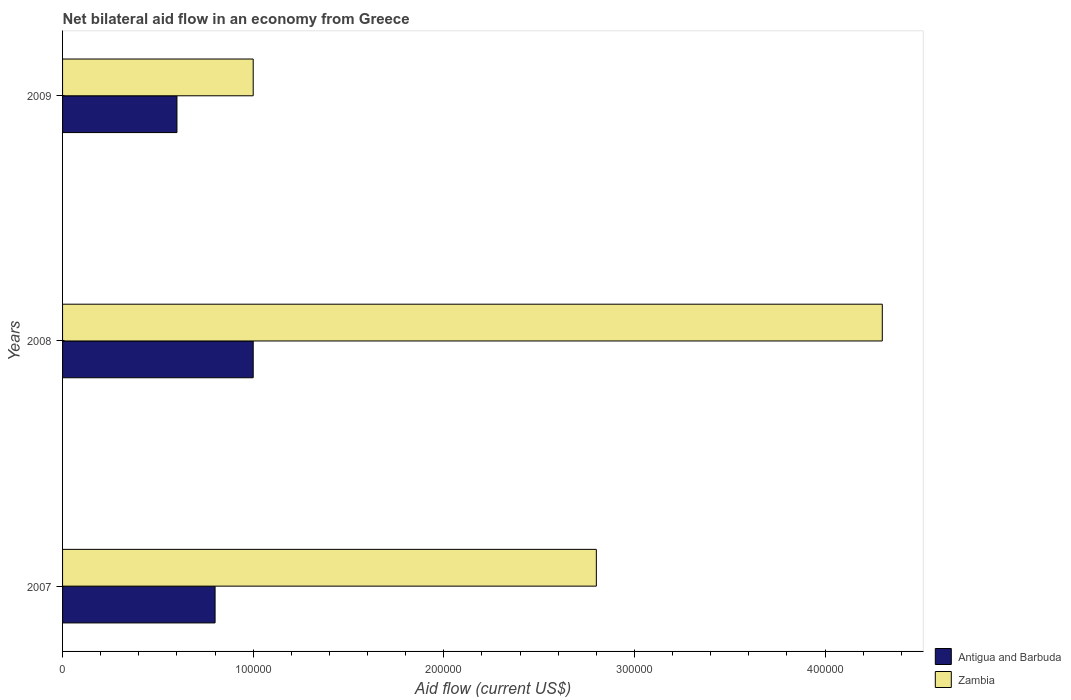How many groups of bars are there?
Your answer should be compact. 3. How many bars are there on the 3rd tick from the top?
Your response must be concise. 2. In how many cases, is the number of bars for a given year not equal to the number of legend labels?
Provide a short and direct response. 0. What is the net bilateral aid flow in Zambia in 2007?
Make the answer very short. 2.80e+05. Across all years, what is the minimum net bilateral aid flow in Antigua and Barbuda?
Keep it short and to the point. 6.00e+04. In which year was the net bilateral aid flow in Zambia maximum?
Ensure brevity in your answer.  2008. In which year was the net bilateral aid flow in Zambia minimum?
Offer a terse response. 2009. What is the total net bilateral aid flow in Zambia in the graph?
Provide a short and direct response. 8.10e+05. What is the difference between the net bilateral aid flow in Zambia in 2007 and that in 2008?
Provide a succinct answer. -1.50e+05. What is the difference between the net bilateral aid flow in Antigua and Barbuda in 2009 and the net bilateral aid flow in Zambia in 2008?
Provide a succinct answer. -3.70e+05. What is the average net bilateral aid flow in Antigua and Barbuda per year?
Your answer should be compact. 8.00e+04. In the year 2009, what is the difference between the net bilateral aid flow in Antigua and Barbuda and net bilateral aid flow in Zambia?
Provide a succinct answer. -4.00e+04. In how many years, is the net bilateral aid flow in Zambia greater than 100000 US$?
Your response must be concise. 2. What is the ratio of the net bilateral aid flow in Antigua and Barbuda in 2007 to that in 2008?
Make the answer very short. 0.8. Is the net bilateral aid flow in Zambia in 2008 less than that in 2009?
Give a very brief answer. No. Is the difference between the net bilateral aid flow in Antigua and Barbuda in 2008 and 2009 greater than the difference between the net bilateral aid flow in Zambia in 2008 and 2009?
Your answer should be very brief. No. What is the difference between the highest and the second highest net bilateral aid flow in Antigua and Barbuda?
Provide a succinct answer. 2.00e+04. In how many years, is the net bilateral aid flow in Zambia greater than the average net bilateral aid flow in Zambia taken over all years?
Give a very brief answer. 2. What does the 1st bar from the top in 2007 represents?
Make the answer very short. Zambia. What does the 2nd bar from the bottom in 2007 represents?
Your response must be concise. Zambia. How many bars are there?
Ensure brevity in your answer.  6. Are all the bars in the graph horizontal?
Keep it short and to the point. Yes. How many years are there in the graph?
Keep it short and to the point. 3. What is the difference between two consecutive major ticks on the X-axis?
Provide a short and direct response. 1.00e+05. Does the graph contain any zero values?
Give a very brief answer. No. How are the legend labels stacked?
Offer a very short reply. Vertical. What is the title of the graph?
Give a very brief answer. Net bilateral aid flow in an economy from Greece. What is the label or title of the Y-axis?
Offer a terse response. Years. What is the Aid flow (current US$) in Antigua and Barbuda in 2007?
Provide a succinct answer. 8.00e+04. What is the Aid flow (current US$) of Antigua and Barbuda in 2008?
Provide a short and direct response. 1.00e+05. What is the Aid flow (current US$) of Zambia in 2008?
Your answer should be very brief. 4.30e+05. What is the Aid flow (current US$) of Zambia in 2009?
Provide a short and direct response. 1.00e+05. Across all years, what is the maximum Aid flow (current US$) of Antigua and Barbuda?
Ensure brevity in your answer.  1.00e+05. Across all years, what is the minimum Aid flow (current US$) in Antigua and Barbuda?
Provide a short and direct response. 6.00e+04. Across all years, what is the minimum Aid flow (current US$) of Zambia?
Give a very brief answer. 1.00e+05. What is the total Aid flow (current US$) in Antigua and Barbuda in the graph?
Offer a terse response. 2.40e+05. What is the total Aid flow (current US$) of Zambia in the graph?
Provide a succinct answer. 8.10e+05. What is the difference between the Aid flow (current US$) of Antigua and Barbuda in 2008 and that in 2009?
Ensure brevity in your answer.  4.00e+04. What is the difference between the Aid flow (current US$) of Antigua and Barbuda in 2007 and the Aid flow (current US$) of Zambia in 2008?
Provide a succinct answer. -3.50e+05. What is the average Aid flow (current US$) of Antigua and Barbuda per year?
Keep it short and to the point. 8.00e+04. In the year 2008, what is the difference between the Aid flow (current US$) in Antigua and Barbuda and Aid flow (current US$) in Zambia?
Keep it short and to the point. -3.30e+05. What is the ratio of the Aid flow (current US$) of Antigua and Barbuda in 2007 to that in 2008?
Keep it short and to the point. 0.8. What is the ratio of the Aid flow (current US$) in Zambia in 2007 to that in 2008?
Give a very brief answer. 0.65. What is the ratio of the Aid flow (current US$) of Antigua and Barbuda in 2007 to that in 2009?
Give a very brief answer. 1.33. What is the ratio of the Aid flow (current US$) of Zambia in 2007 to that in 2009?
Make the answer very short. 2.8. What is the ratio of the Aid flow (current US$) in Zambia in 2008 to that in 2009?
Give a very brief answer. 4.3. What is the difference between the highest and the second highest Aid flow (current US$) of Antigua and Barbuda?
Make the answer very short. 2.00e+04. What is the difference between the highest and the lowest Aid flow (current US$) of Antigua and Barbuda?
Ensure brevity in your answer.  4.00e+04. What is the difference between the highest and the lowest Aid flow (current US$) in Zambia?
Provide a short and direct response. 3.30e+05. 